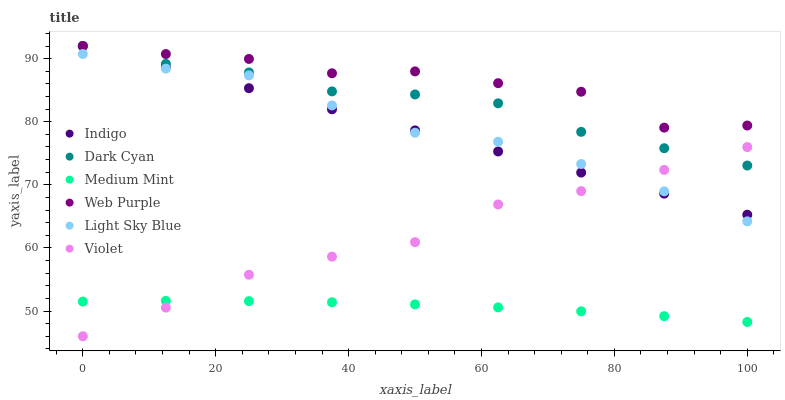Does Medium Mint have the minimum area under the curve?
Answer yes or no. Yes. Does Web Purple have the maximum area under the curve?
Answer yes or no. Yes. Does Indigo have the minimum area under the curve?
Answer yes or no. No. Does Indigo have the maximum area under the curve?
Answer yes or no. No. Is Indigo the smoothest?
Answer yes or no. Yes. Is Web Purple the roughest?
Answer yes or no. Yes. Is Web Purple the smoothest?
Answer yes or no. No. Is Indigo the roughest?
Answer yes or no. No. Does Violet have the lowest value?
Answer yes or no. Yes. Does Indigo have the lowest value?
Answer yes or no. No. Does Dark Cyan have the highest value?
Answer yes or no. Yes. Does Light Sky Blue have the highest value?
Answer yes or no. No. Is Medium Mint less than Light Sky Blue?
Answer yes or no. Yes. Is Web Purple greater than Violet?
Answer yes or no. Yes. Does Dark Cyan intersect Web Purple?
Answer yes or no. Yes. Is Dark Cyan less than Web Purple?
Answer yes or no. No. Is Dark Cyan greater than Web Purple?
Answer yes or no. No. Does Medium Mint intersect Light Sky Blue?
Answer yes or no. No. 